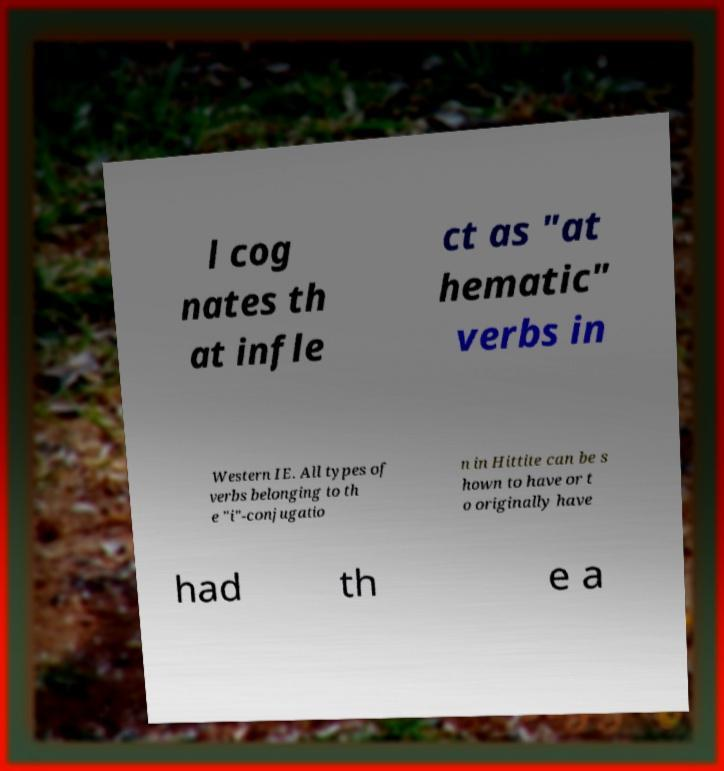Please identify and transcribe the text found in this image. l cog nates th at infle ct as "at hematic" verbs in Western IE. All types of verbs belonging to th e "i"-conjugatio n in Hittite can be s hown to have or t o originally have had th e a 